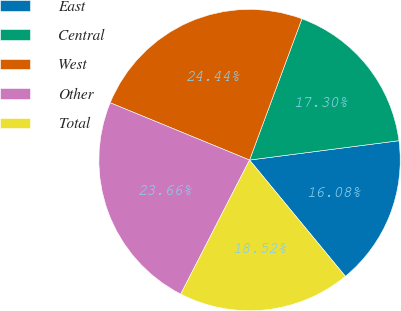Convert chart to OTSL. <chart><loc_0><loc_0><loc_500><loc_500><pie_chart><fcel>East<fcel>Central<fcel>West<fcel>Other<fcel>Total<nl><fcel>16.08%<fcel>17.3%<fcel>24.44%<fcel>23.66%<fcel>18.52%<nl></chart> 